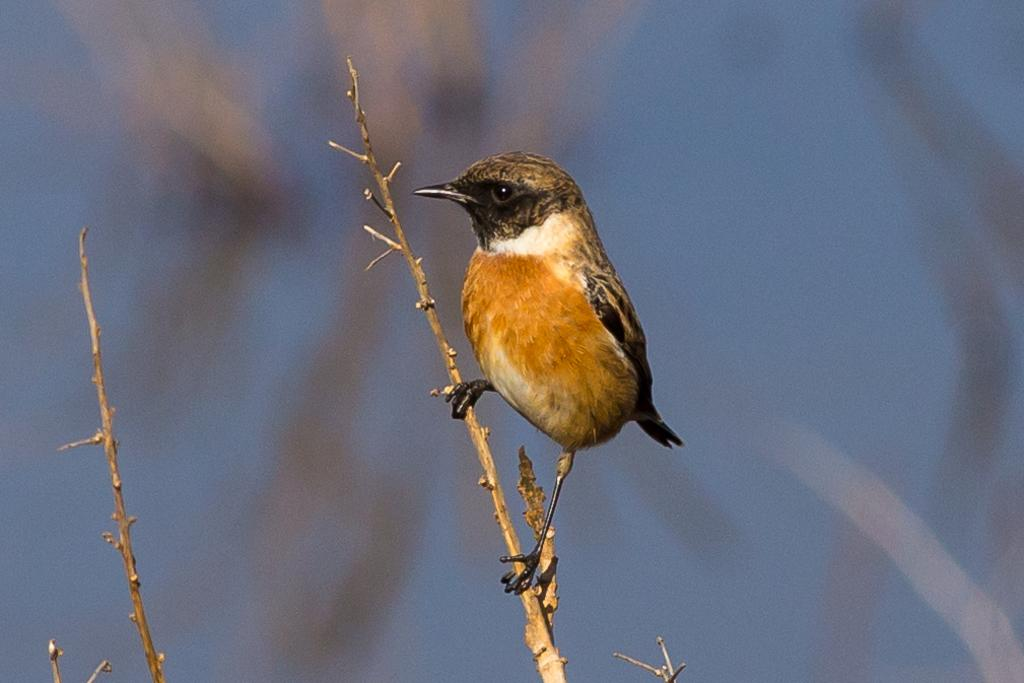What type of animal is in the image? There is a bird in the image. What is the bird standing on? The bird is standing on a stem. Can you describe the background of the image? The background of the image is blurry. What type of plantation can be seen in the background of the image? There is no plantation present in the image; the background is blurry. What type of fuel is the bird using to stand on the stem? Birds do not use fuel to stand; they use their legs and feet for support. 